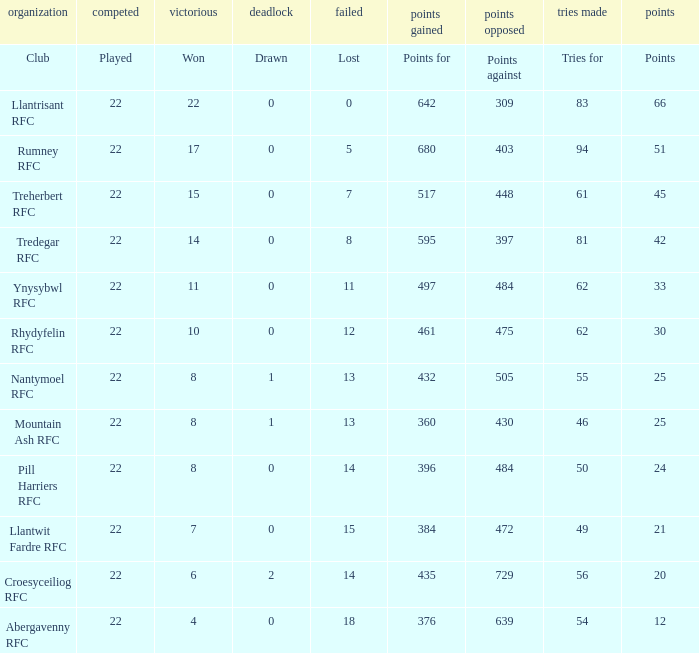How many matches were drawn by the teams that won exactly 10? 1.0. 